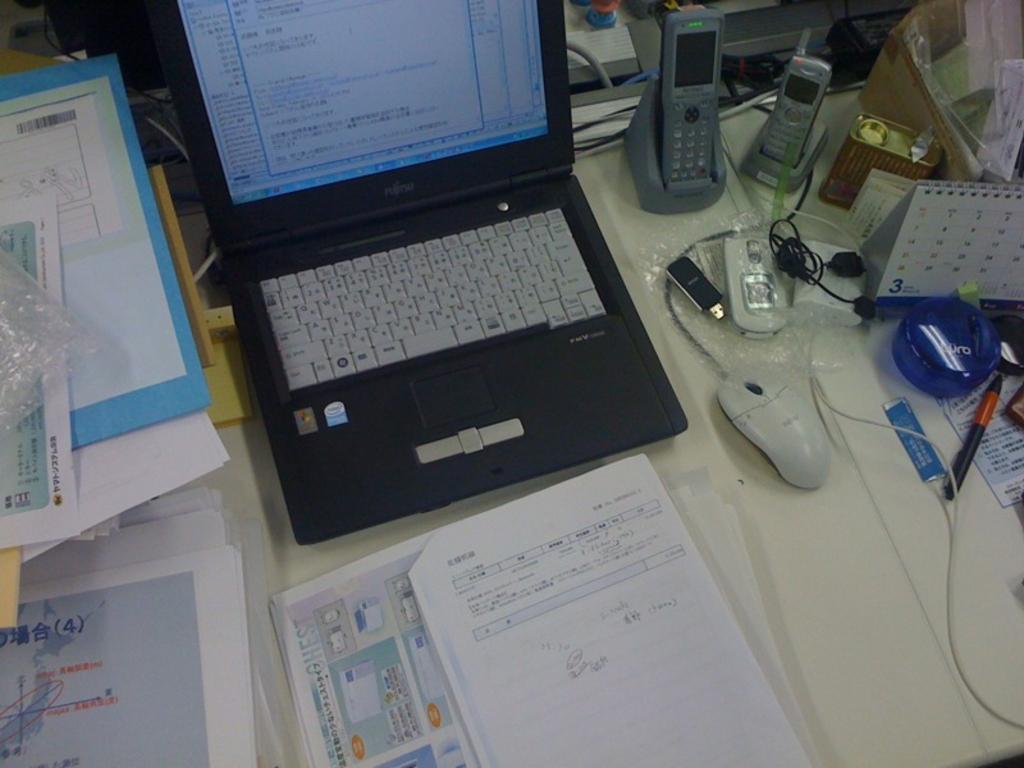What is the number inside the (parenthesis) on the paper in the bottom left?
Your answer should be compact. 4. 